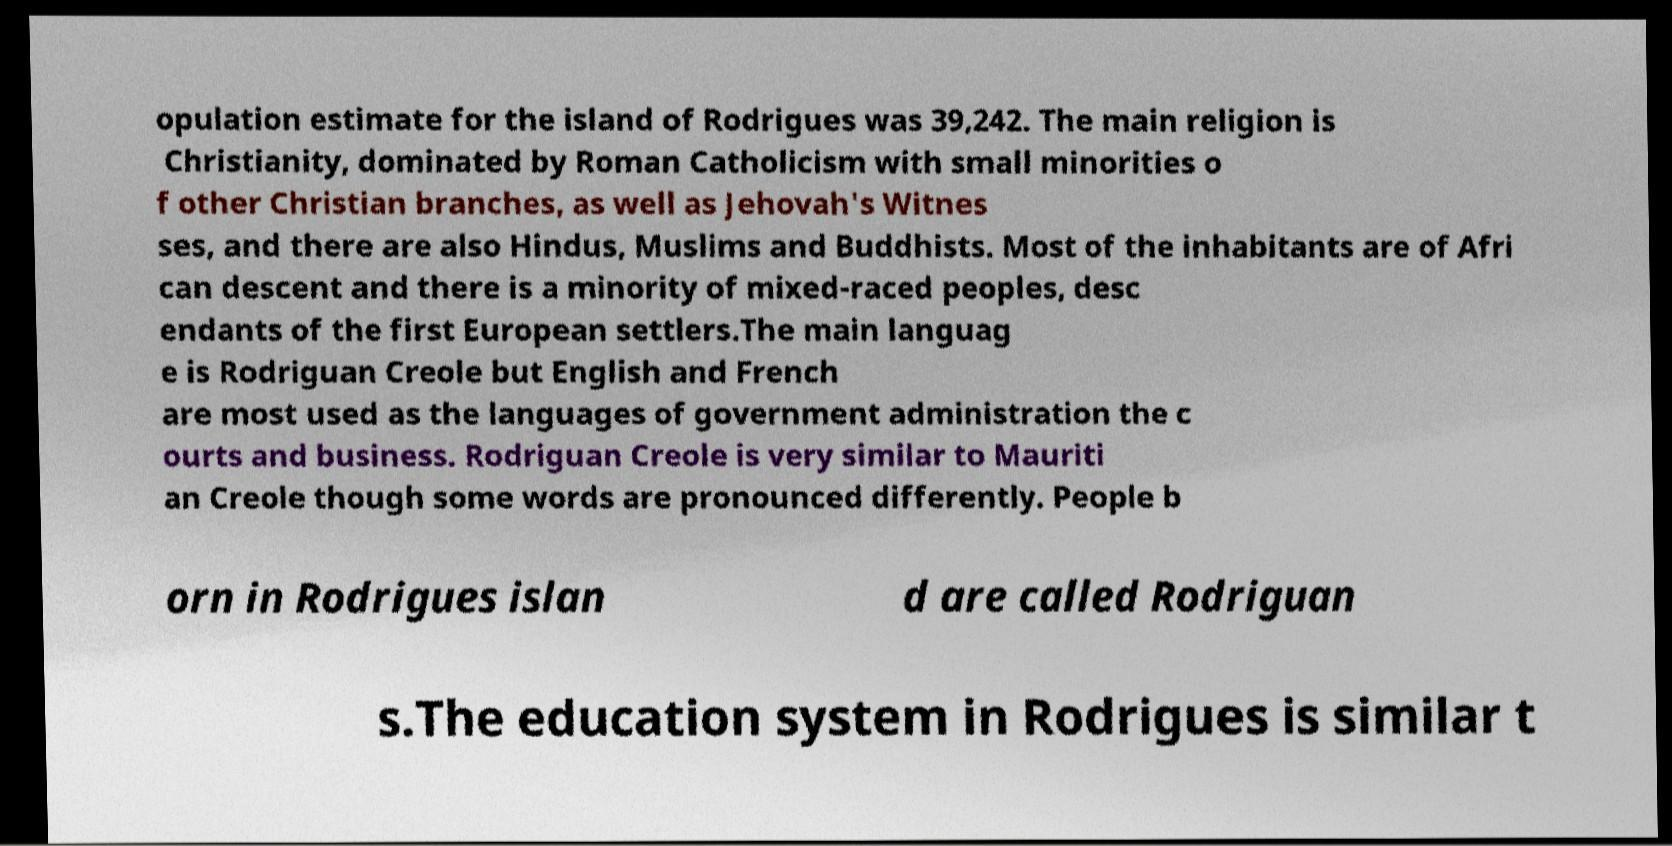There's text embedded in this image that I need extracted. Can you transcribe it verbatim? opulation estimate for the island of Rodrigues was 39,242. The main religion is Christianity, dominated by Roman Catholicism with small minorities o f other Christian branches, as well as Jehovah's Witnes ses, and there are also Hindus, Muslims and Buddhists. Most of the inhabitants are of Afri can descent and there is a minority of mixed-raced peoples, desc endants of the first European settlers.The main languag e is Rodriguan Creole but English and French are most used as the languages of government administration the c ourts and business. Rodriguan Creole is very similar to Mauriti an Creole though some words are pronounced differently. People b orn in Rodrigues islan d are called Rodriguan s.The education system in Rodrigues is similar t 